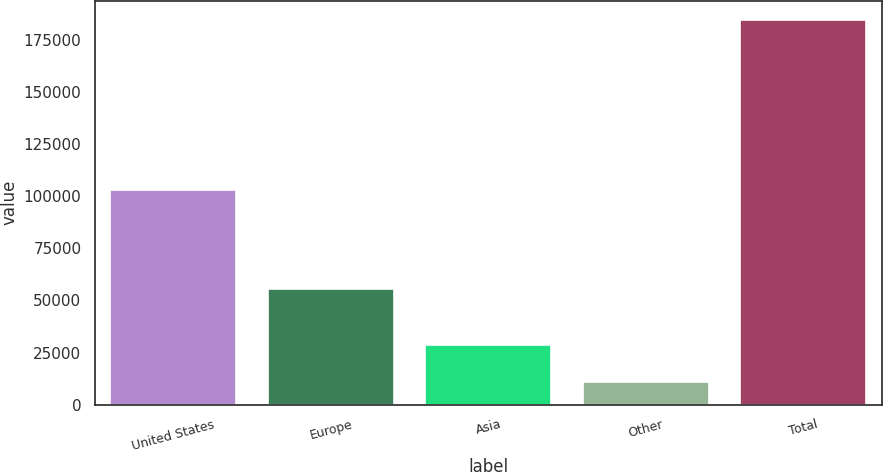<chart> <loc_0><loc_0><loc_500><loc_500><bar_chart><fcel>United States<fcel>Europe<fcel>Asia<fcel>Other<fcel>Total<nl><fcel>103043<fcel>55440<fcel>28388.3<fcel>11033<fcel>184586<nl></chart> 